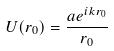<formula> <loc_0><loc_0><loc_500><loc_500>U ( r _ { 0 } ) = \frac { a e ^ { i k r _ { 0 } } } { r _ { 0 } }</formula> 